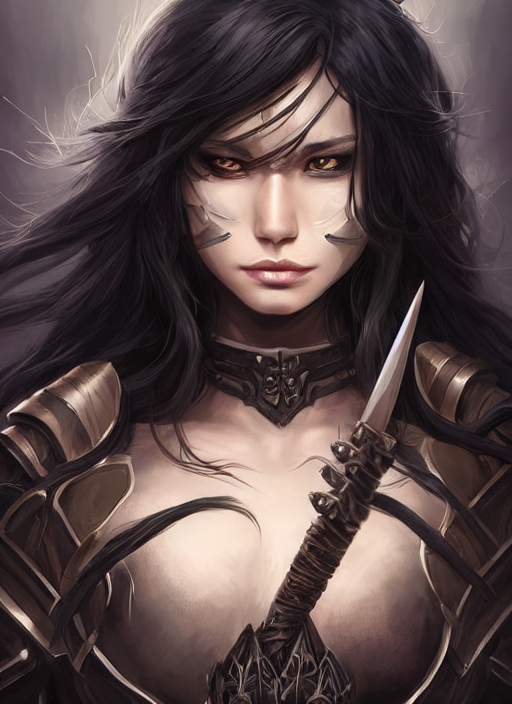Can you describe the style and elements of the armor worn by the character? Certainly. The character is clad in a fantasy-inspired armor with intricate designs. The armor marries functionality with aesthetic appeal - it features curved metal plates that provide protection while highlighting a formidable yet elegant appearance. The shoulder pauldrons have sharp, wing-like extensions, and the chest plate is adorned with what seems to be a symbol of rank or allegiance, perhaps signifying a high-status warrior. 